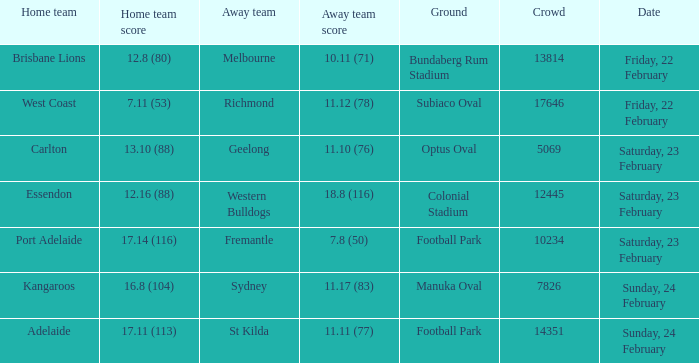What score did the away team receive against home team Port Adelaide? 7.8 (50). 